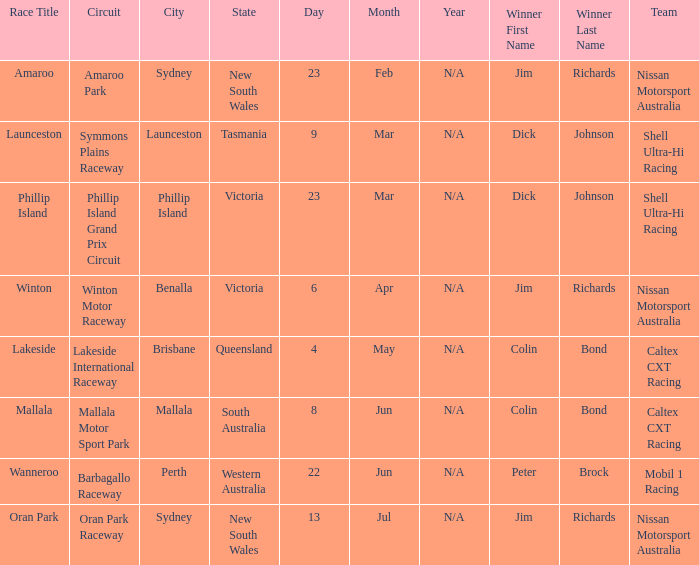Name the date for race title lakeside 4 – 6 May. 